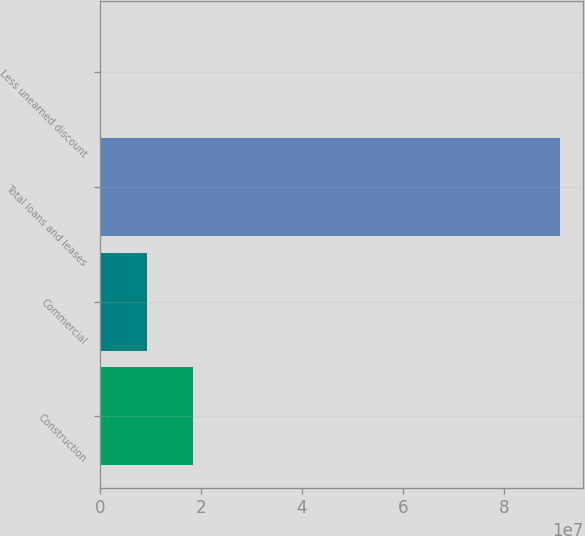Convert chart to OTSL. <chart><loc_0><loc_0><loc_500><loc_500><bar_chart><fcel>Construction<fcel>Commercial<fcel>Total loans and leases<fcel>Less unearned discount<nl><fcel>1.84189e+07<fcel>9.3336e+06<fcel>9.11017e+07<fcel>248261<nl></chart> 